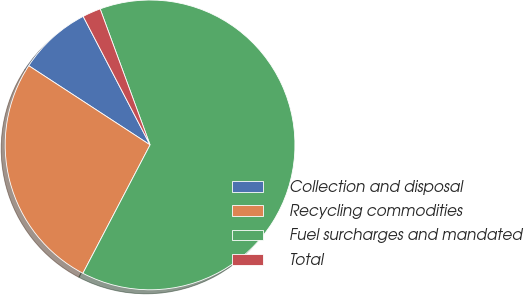Convert chart. <chart><loc_0><loc_0><loc_500><loc_500><pie_chart><fcel>Collection and disposal<fcel>Recycling commodities<fcel>Fuel surcharges and mandated<fcel>Total<nl><fcel>8.16%<fcel>26.53%<fcel>63.27%<fcel>2.04%<nl></chart> 